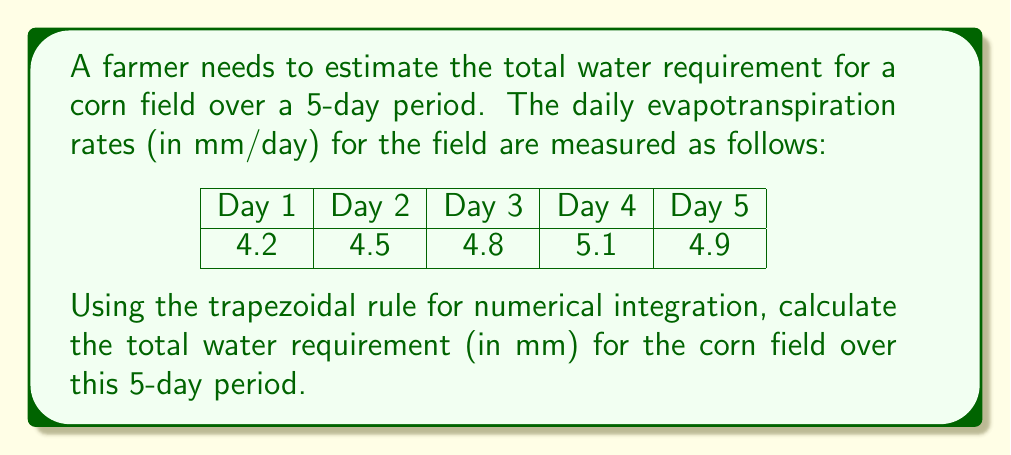What is the answer to this math problem? To estimate the total water requirement, we need to integrate the evapotranspiration rates over the given time period. Since we have discrete daily measurements, we can use the trapezoidal rule for numerical integration.

The trapezoidal rule for n intervals is given by:

$$ \int_{a}^{b} f(x) dx \approx \frac{h}{2} [f(x_0) + 2f(x_1) + 2f(x_2) + ... + 2f(x_{n-1}) + f(x_n)] $$

Where h is the width of each interval (in this case, 1 day).

Given data:
$f(x_0) = 4.2$, $f(x_1) = 4.5$, $f(x_2) = 4.8$, $f(x_3) = 5.1$, $f(x_4) = 4.9$

Applying the trapezoidal rule:

$$ \text{Total Water Requirement} \approx \frac{1}{2} [4.2 + 2(4.5) + 2(4.8) + 2(5.1) + 4.9] $$

$$ = \frac{1}{2} [4.2 + 9.0 + 9.6 + 10.2 + 4.9] $$

$$ = \frac{1}{2} [37.9] $$

$$ = 18.95 \text{ mm} $$

Therefore, the estimated total water requirement for the corn field over the 5-day period is 18.95 mm.
Answer: 18.95 mm 